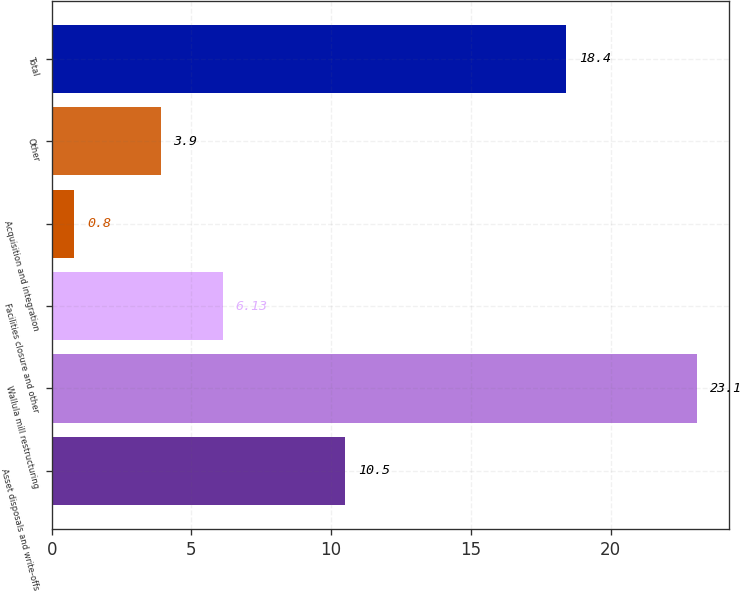Convert chart. <chart><loc_0><loc_0><loc_500><loc_500><bar_chart><fcel>Asset disposals and write-offs<fcel>Wallula mill restructuring<fcel>Facilities closure and other<fcel>Acquisition and integration<fcel>Other<fcel>Total<nl><fcel>10.5<fcel>23.1<fcel>6.13<fcel>0.8<fcel>3.9<fcel>18.4<nl></chart> 